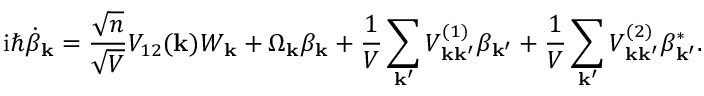Convert formula to latex. <formula><loc_0><loc_0><loc_500><loc_500>i \hbar { \dot } { \beta } _ { k } = \frac { \sqrt { n } } { \sqrt { V } } V _ { 1 2 } ( k ) W _ { k } + \Omega _ { k } \beta _ { k } + \frac { 1 } { V } \sum _ { k ^ { \prime } } V _ { k k ^ { \prime } } ^ { ( 1 ) } \beta _ { k ^ { \prime } } + \frac { 1 } { V } \sum _ { k ^ { \prime } } V _ { k k ^ { \prime } } ^ { ( 2 ) } \beta _ { k ^ { \prime } } ^ { * } .</formula> 